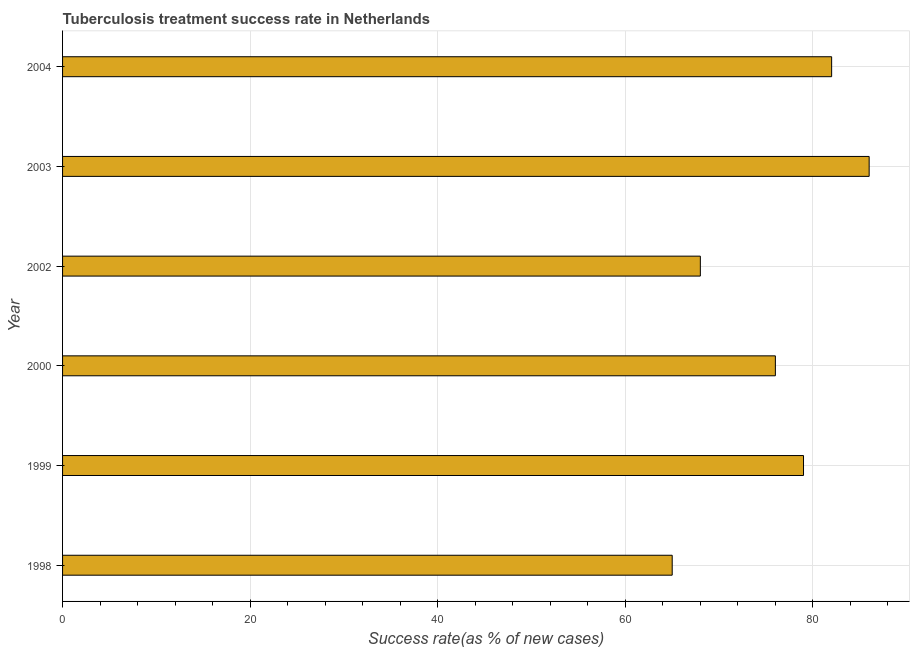Does the graph contain grids?
Your answer should be compact. Yes. What is the title of the graph?
Make the answer very short. Tuberculosis treatment success rate in Netherlands. What is the label or title of the X-axis?
Make the answer very short. Success rate(as % of new cases). What is the tuberculosis treatment success rate in 2004?
Provide a succinct answer. 82. In which year was the tuberculosis treatment success rate minimum?
Make the answer very short. 1998. What is the sum of the tuberculosis treatment success rate?
Give a very brief answer. 456. What is the difference between the tuberculosis treatment success rate in 1999 and 2003?
Your answer should be very brief. -7. What is the average tuberculosis treatment success rate per year?
Your response must be concise. 76. What is the median tuberculosis treatment success rate?
Your answer should be very brief. 77.5. What is the ratio of the tuberculosis treatment success rate in 2002 to that in 2003?
Keep it short and to the point. 0.79. What is the difference between the highest and the second highest tuberculosis treatment success rate?
Your answer should be compact. 4. What is the difference between two consecutive major ticks on the X-axis?
Give a very brief answer. 20. Are the values on the major ticks of X-axis written in scientific E-notation?
Offer a terse response. No. What is the Success rate(as % of new cases) of 1999?
Your answer should be compact. 79. What is the Success rate(as % of new cases) in 2000?
Keep it short and to the point. 76. What is the Success rate(as % of new cases) in 2002?
Your answer should be compact. 68. What is the Success rate(as % of new cases) in 2003?
Give a very brief answer. 86. What is the Success rate(as % of new cases) in 2004?
Keep it short and to the point. 82. What is the difference between the Success rate(as % of new cases) in 1998 and 1999?
Give a very brief answer. -14. What is the difference between the Success rate(as % of new cases) in 1998 and 2000?
Your answer should be compact. -11. What is the difference between the Success rate(as % of new cases) in 1998 and 2002?
Provide a short and direct response. -3. What is the difference between the Success rate(as % of new cases) in 1998 and 2003?
Ensure brevity in your answer.  -21. What is the difference between the Success rate(as % of new cases) in 1998 and 2004?
Give a very brief answer. -17. What is the difference between the Success rate(as % of new cases) in 1999 and 2000?
Your answer should be compact. 3. What is the difference between the Success rate(as % of new cases) in 1999 and 2002?
Ensure brevity in your answer.  11. What is the difference between the Success rate(as % of new cases) in 1999 and 2003?
Your response must be concise. -7. What is the difference between the Success rate(as % of new cases) in 1999 and 2004?
Your answer should be compact. -3. What is the difference between the Success rate(as % of new cases) in 2002 and 2004?
Make the answer very short. -14. What is the ratio of the Success rate(as % of new cases) in 1998 to that in 1999?
Provide a succinct answer. 0.82. What is the ratio of the Success rate(as % of new cases) in 1998 to that in 2000?
Your answer should be very brief. 0.85. What is the ratio of the Success rate(as % of new cases) in 1998 to that in 2002?
Make the answer very short. 0.96. What is the ratio of the Success rate(as % of new cases) in 1998 to that in 2003?
Offer a terse response. 0.76. What is the ratio of the Success rate(as % of new cases) in 1998 to that in 2004?
Offer a terse response. 0.79. What is the ratio of the Success rate(as % of new cases) in 1999 to that in 2000?
Keep it short and to the point. 1.04. What is the ratio of the Success rate(as % of new cases) in 1999 to that in 2002?
Ensure brevity in your answer.  1.16. What is the ratio of the Success rate(as % of new cases) in 1999 to that in 2003?
Make the answer very short. 0.92. What is the ratio of the Success rate(as % of new cases) in 2000 to that in 2002?
Your answer should be compact. 1.12. What is the ratio of the Success rate(as % of new cases) in 2000 to that in 2003?
Make the answer very short. 0.88. What is the ratio of the Success rate(as % of new cases) in 2000 to that in 2004?
Your answer should be compact. 0.93. What is the ratio of the Success rate(as % of new cases) in 2002 to that in 2003?
Your response must be concise. 0.79. What is the ratio of the Success rate(as % of new cases) in 2002 to that in 2004?
Give a very brief answer. 0.83. What is the ratio of the Success rate(as % of new cases) in 2003 to that in 2004?
Your answer should be very brief. 1.05. 